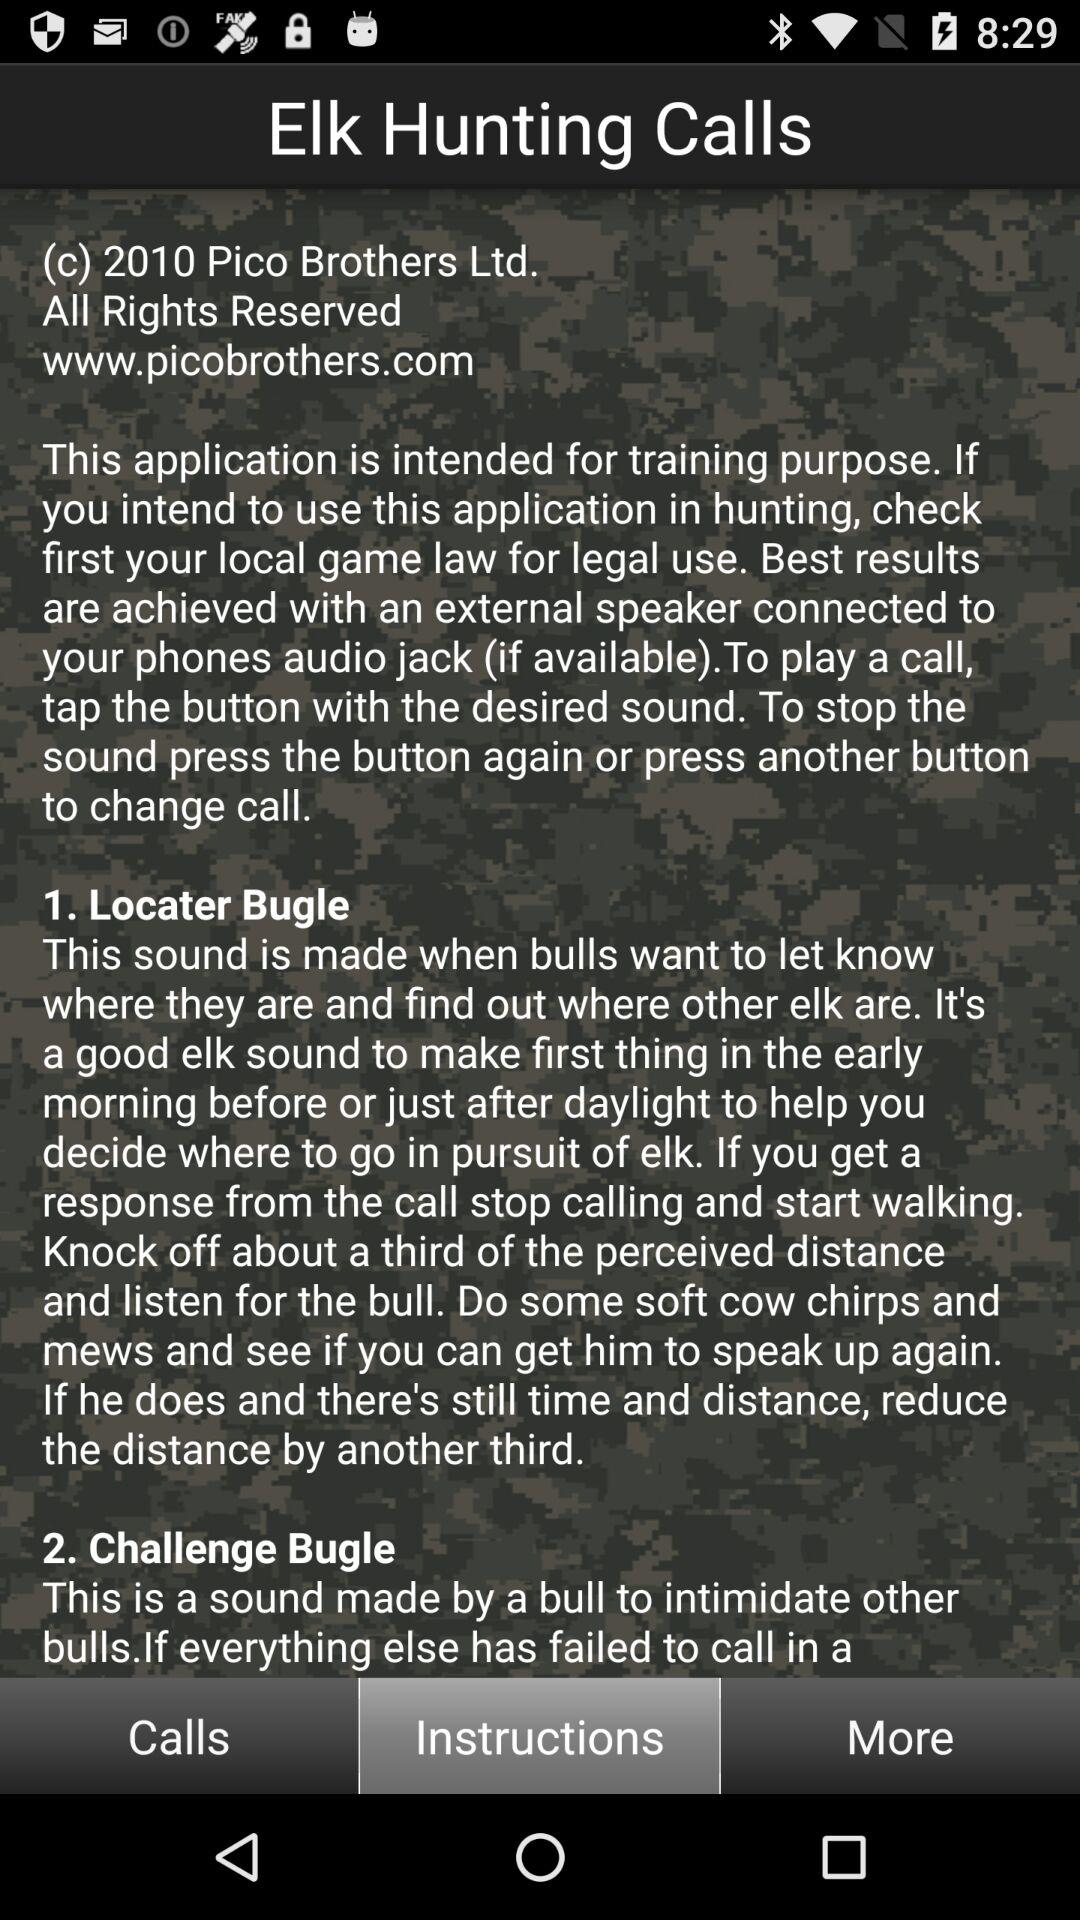What is a Locator Bugle? The Locator Bugle is the sound that is made when bulls want to let you know where they are and find out where other elk are. It's a good elk sound to make first thing in the early morning before or just after daylight to help you decide where to go in pursuit of elk. If you get a response from the call, stop calling and start walking. Knock off about a third of the perceived distance and listen for the bull. Do some soft cow chirps and mews and see if you can get him to speak up again. If he does and there's still time and distance, reduce the distance by another third. 